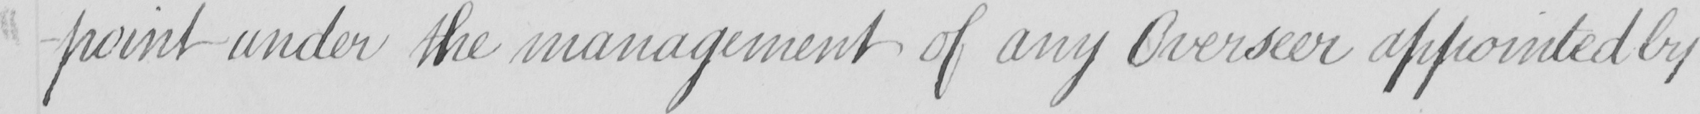Transcribe the text shown in this historical manuscript line. -point under the management of any Overseer appointed by 